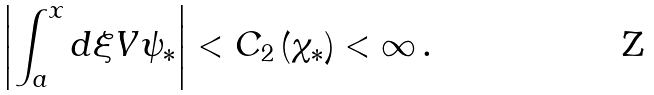Convert formula to latex. <formula><loc_0><loc_0><loc_500><loc_500>\left | \int _ { a } ^ { x } d \xi V \psi _ { \ast } \right | < C _ { 2 } \left ( \chi _ { \ast } \right ) < \infty \, .</formula> 